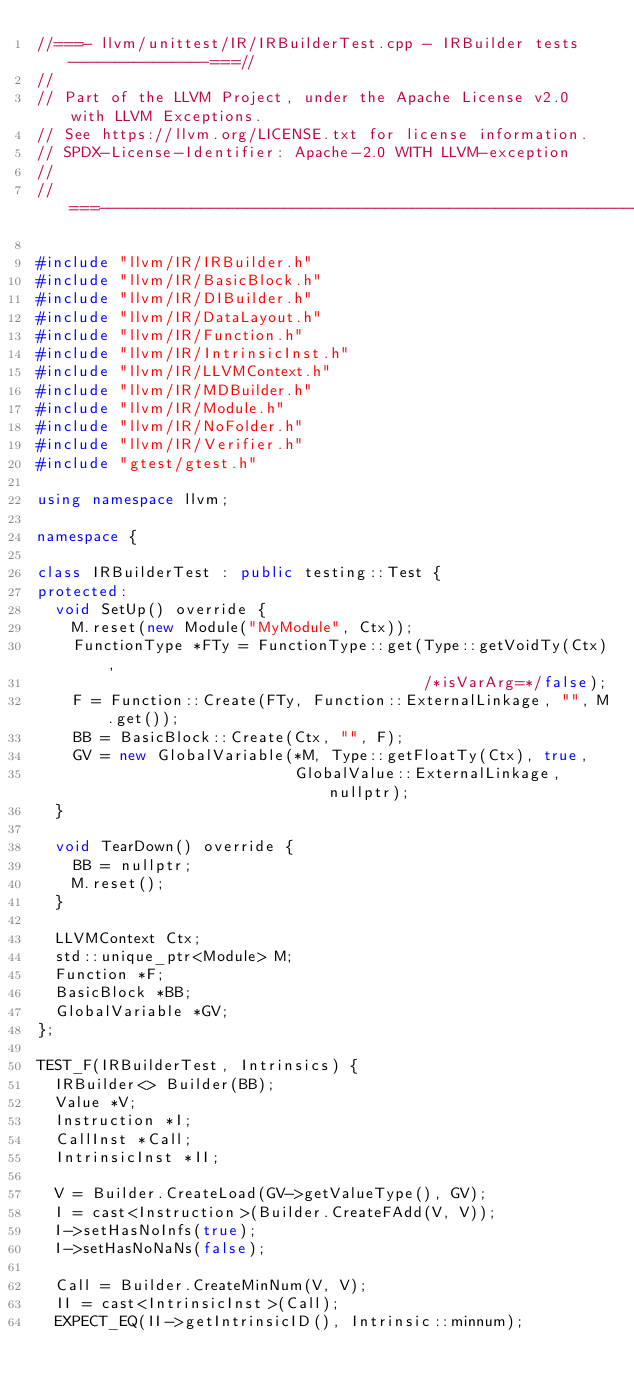Convert code to text. <code><loc_0><loc_0><loc_500><loc_500><_C++_>//===- llvm/unittest/IR/IRBuilderTest.cpp - IRBuilder tests ---------------===//
//
// Part of the LLVM Project, under the Apache License v2.0 with LLVM Exceptions.
// See https://llvm.org/LICENSE.txt for license information.
// SPDX-License-Identifier: Apache-2.0 WITH LLVM-exception
//
//===----------------------------------------------------------------------===//

#include "llvm/IR/IRBuilder.h"
#include "llvm/IR/BasicBlock.h"
#include "llvm/IR/DIBuilder.h"
#include "llvm/IR/DataLayout.h"
#include "llvm/IR/Function.h"
#include "llvm/IR/IntrinsicInst.h"
#include "llvm/IR/LLVMContext.h"
#include "llvm/IR/MDBuilder.h"
#include "llvm/IR/Module.h"
#include "llvm/IR/NoFolder.h"
#include "llvm/IR/Verifier.h"
#include "gtest/gtest.h"

using namespace llvm;

namespace {

class IRBuilderTest : public testing::Test {
protected:
  void SetUp() override {
    M.reset(new Module("MyModule", Ctx));
    FunctionType *FTy = FunctionType::get(Type::getVoidTy(Ctx),
                                          /*isVarArg=*/false);
    F = Function::Create(FTy, Function::ExternalLinkage, "", M.get());
    BB = BasicBlock::Create(Ctx, "", F);
    GV = new GlobalVariable(*M, Type::getFloatTy(Ctx), true,
                            GlobalValue::ExternalLinkage, nullptr);
  }

  void TearDown() override {
    BB = nullptr;
    M.reset();
  }

  LLVMContext Ctx;
  std::unique_ptr<Module> M;
  Function *F;
  BasicBlock *BB;
  GlobalVariable *GV;
};

TEST_F(IRBuilderTest, Intrinsics) {
  IRBuilder<> Builder(BB);
  Value *V;
  Instruction *I;
  CallInst *Call;
  IntrinsicInst *II;

  V = Builder.CreateLoad(GV->getValueType(), GV);
  I = cast<Instruction>(Builder.CreateFAdd(V, V));
  I->setHasNoInfs(true);
  I->setHasNoNaNs(false);

  Call = Builder.CreateMinNum(V, V);
  II = cast<IntrinsicInst>(Call);
  EXPECT_EQ(II->getIntrinsicID(), Intrinsic::minnum);
</code> 